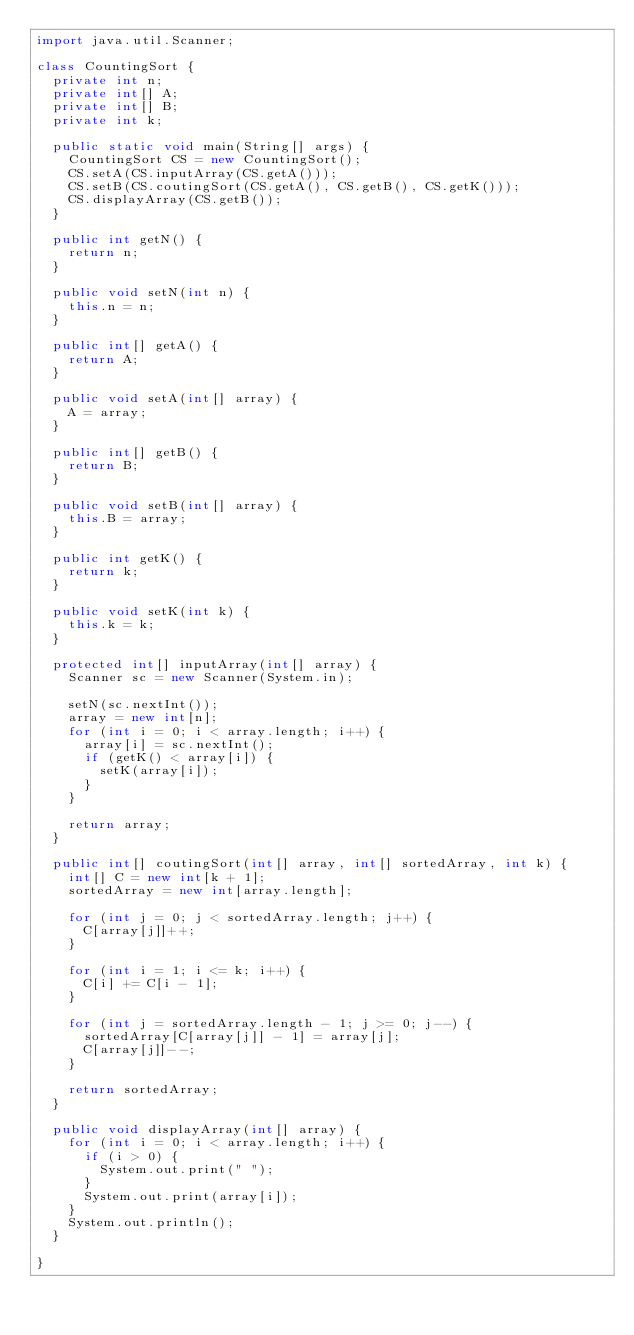<code> <loc_0><loc_0><loc_500><loc_500><_Java_>import java.util.Scanner;

class CountingSort {
	private int n;
	private int[] A;
	private int[] B;
	private int k;

	public static void main(String[] args) {
		CountingSort CS = new CountingSort();
		CS.setA(CS.inputArray(CS.getA()));
		CS.setB(CS.coutingSort(CS.getA(), CS.getB(), CS.getK()));
		CS.displayArray(CS.getB());
	}

	public int getN() {
		return n;
	}

	public void setN(int n) {
		this.n = n;
	}

	public int[] getA() {
		return A;
	}

	public void setA(int[] array) {
		A = array;
	}

	public int[] getB() {
		return B;
	}

	public void setB(int[] array) {
		this.B = array;
	}

	public int getK() {
		return k;
	}

	public void setK(int k) {
		this.k = k;
	}

	protected int[] inputArray(int[] array) {
		Scanner sc = new Scanner(System.in);

		setN(sc.nextInt());
		array = new int[n];
		for (int i = 0; i < array.length; i++) {
			array[i] = sc.nextInt();
			if (getK() < array[i]) {
				setK(array[i]);
			}
		}

		return array;
	}

	public int[] coutingSort(int[] array, int[] sortedArray, int k) {
		int[] C = new int[k + 1];
		sortedArray = new int[array.length];

		for (int j = 0; j < sortedArray.length; j++) {
			C[array[j]]++;
		}

		for (int i = 1; i <= k; i++) {
			C[i] += C[i - 1];
		}

		for (int j = sortedArray.length - 1; j >= 0; j--) {
			sortedArray[C[array[j]] - 1] = array[j];
			C[array[j]]--;
		}

		return sortedArray;
	}

	public void displayArray(int[] array) {
		for (int i = 0; i < array.length; i++) {
			if (i > 0) {
				System.out.print(" ");
			}
			System.out.print(array[i]);
		}
		System.out.println();
	}

}</code> 